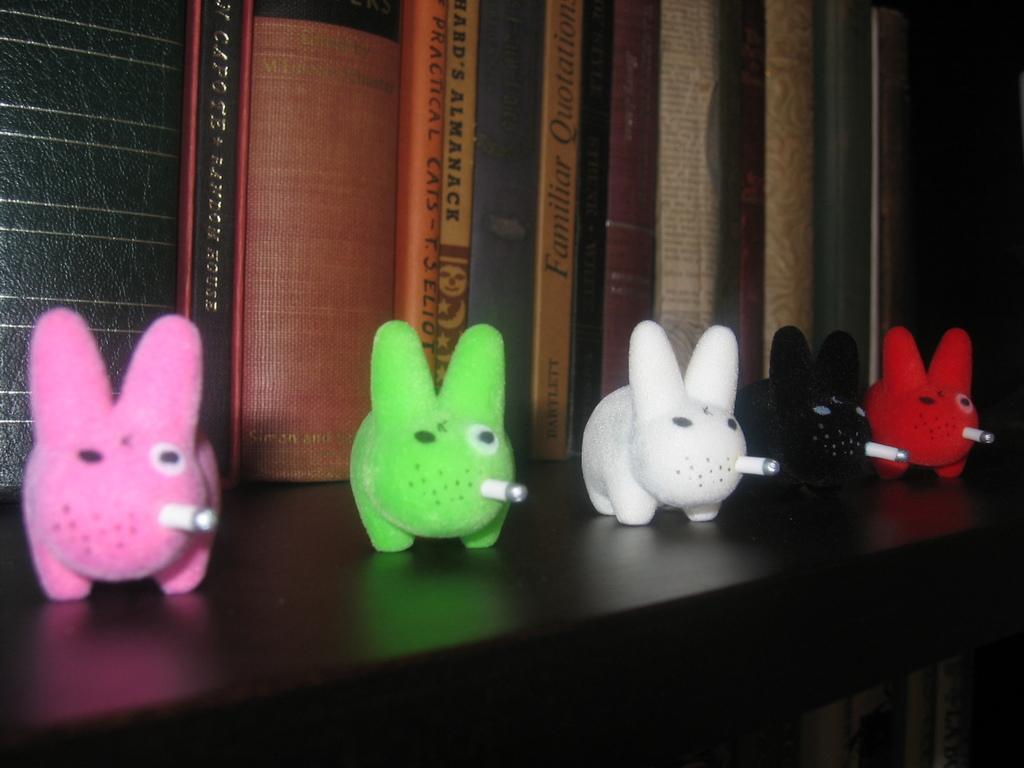Please provide a concise description of this image. In this image there is a table on which there are five toys of different colours. In the background there are books. All the toys are having the cigar in their mouth. 